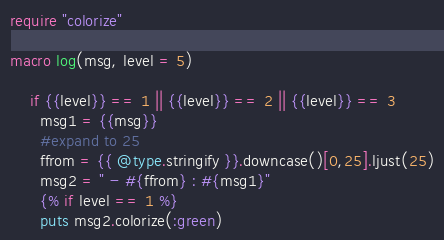<code> <loc_0><loc_0><loc_500><loc_500><_Crystal_>require "colorize"

macro log(msg, level = 5)
  
    if {{level}} == 1 || {{level}} == 2 || {{level}} == 3
      msg1 = {{msg}}
      #expand to 25
      ffrom = {{ @type.stringify }}.downcase()[0,25].ljust(25)
      msg2 = " - #{ffrom} : #{msg1}" 
      {% if level == 1 %}
      puts msg2.colorize(:green)</code> 